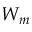<formula> <loc_0><loc_0><loc_500><loc_500>W _ { m }</formula> 